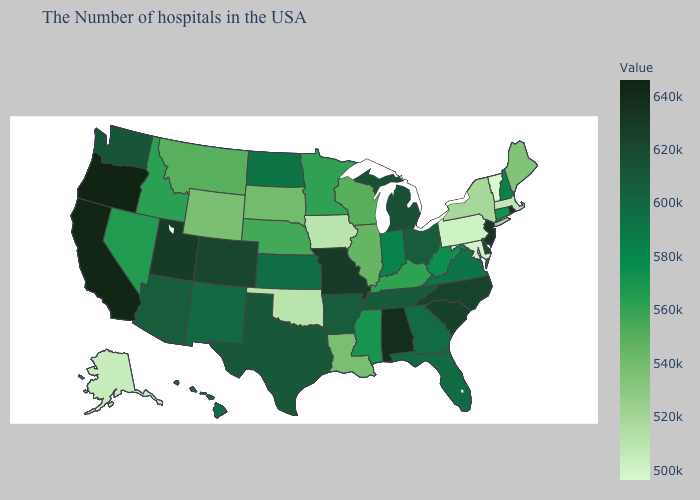Does Tennessee have the lowest value in the USA?
Answer briefly. No. Does Oregon have a lower value than Oklahoma?
Be succinct. No. Does the map have missing data?
Give a very brief answer. No. Which states hav the highest value in the West?
Give a very brief answer. Oregon. 